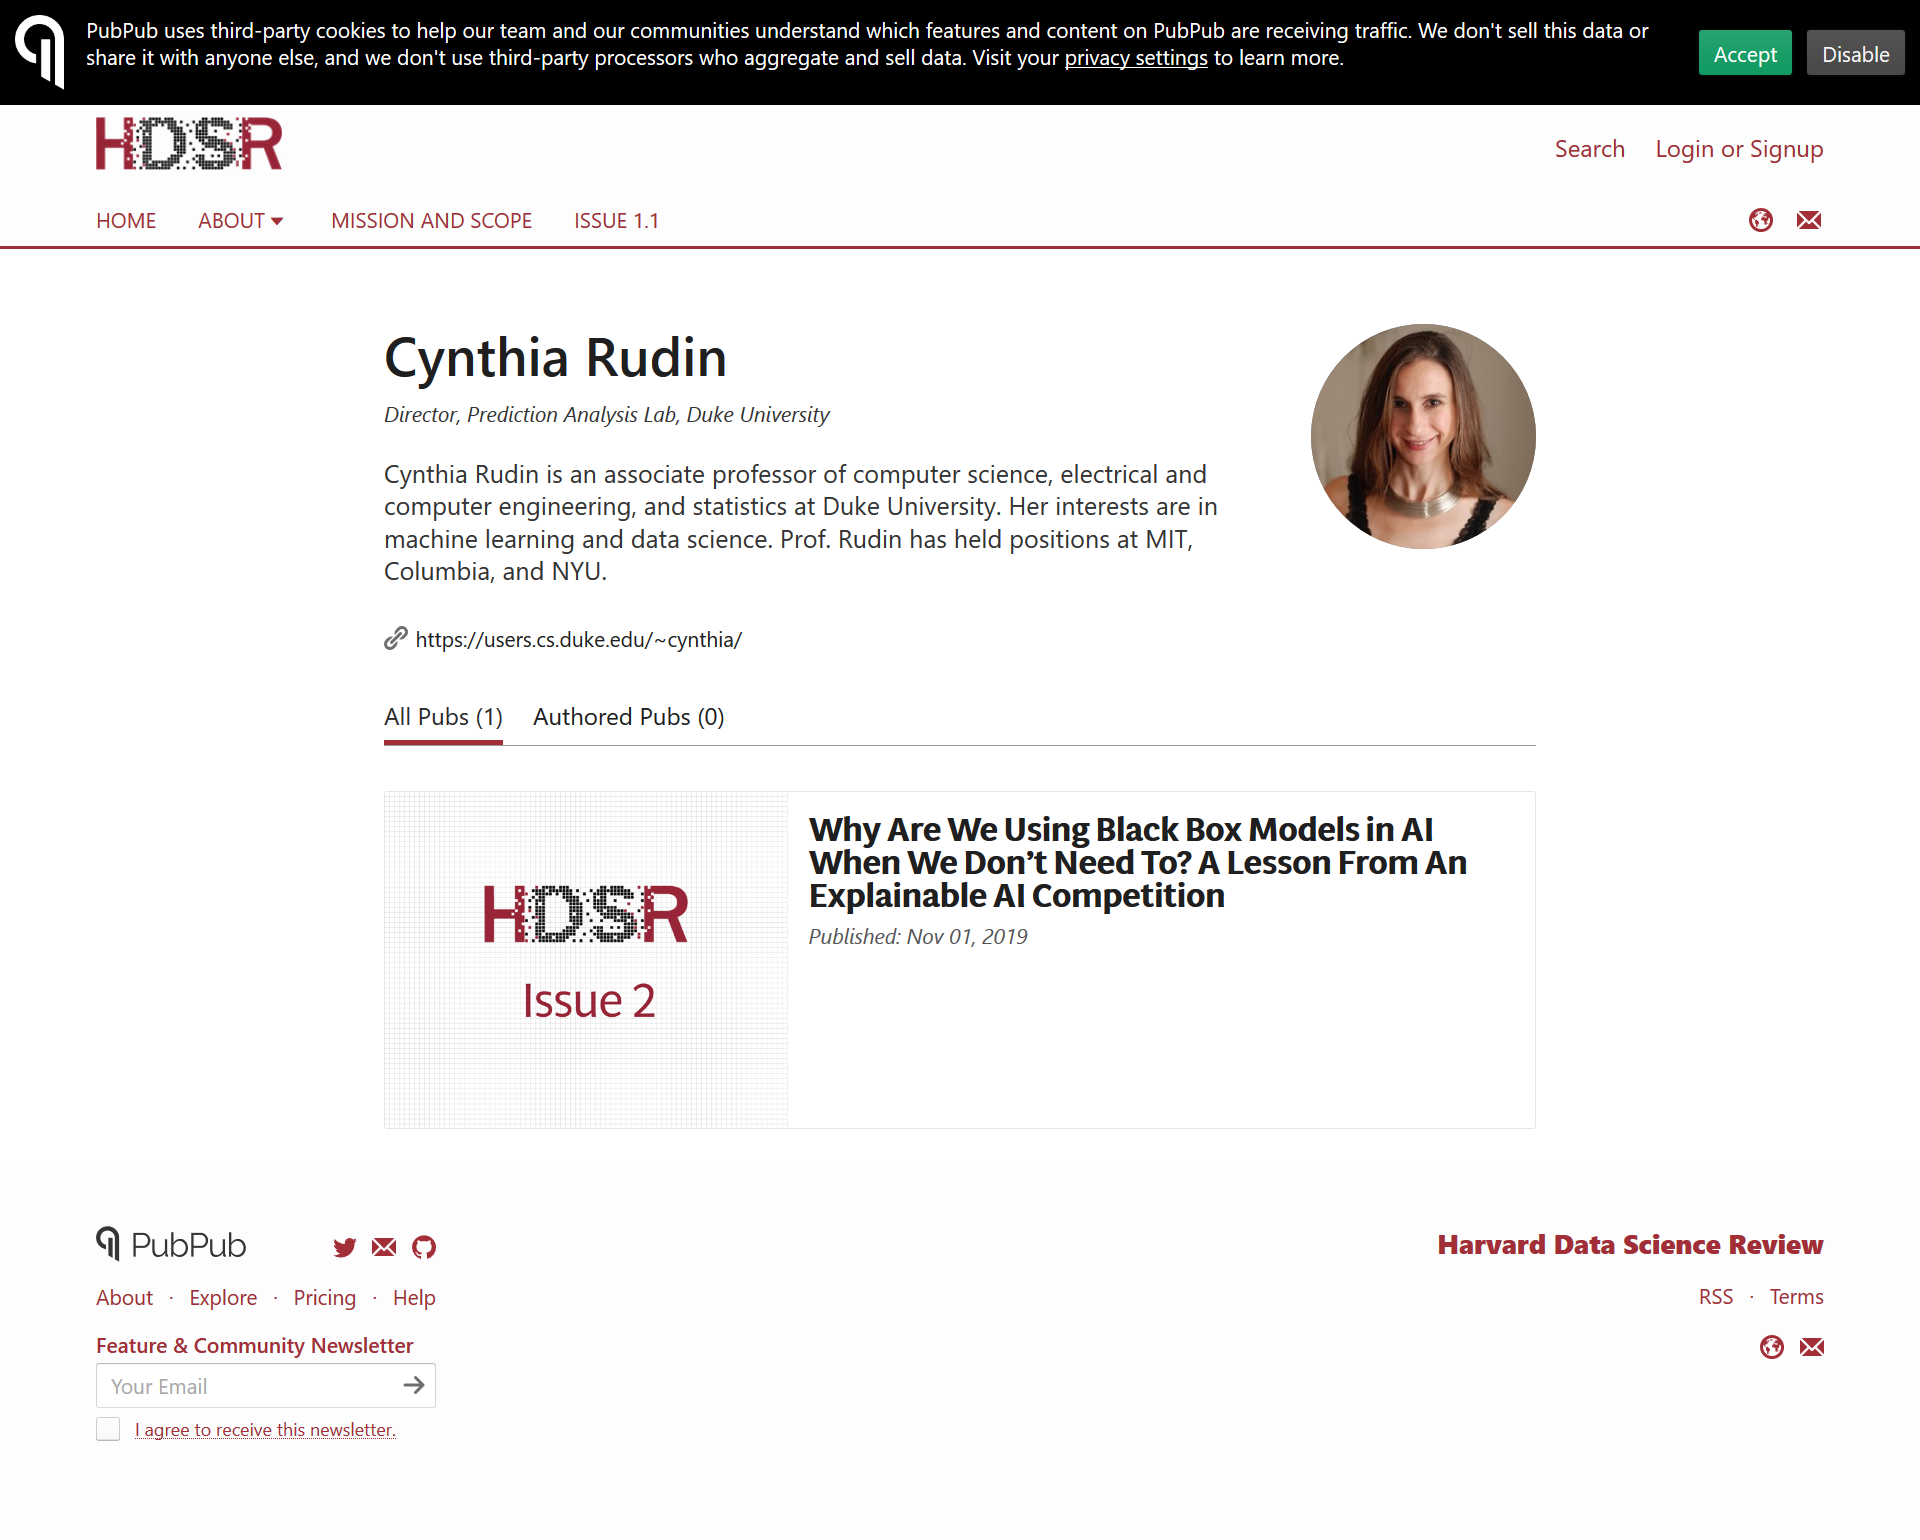Mention a couple of crucial points in this snapshot. The article was published on November 1, 2019, in the HDSR Issue 2. Cynthia Rudin has held positions at MIT, Columbia, and NYU. Cynthia Rudin is the author of "What is the name of the author?". 